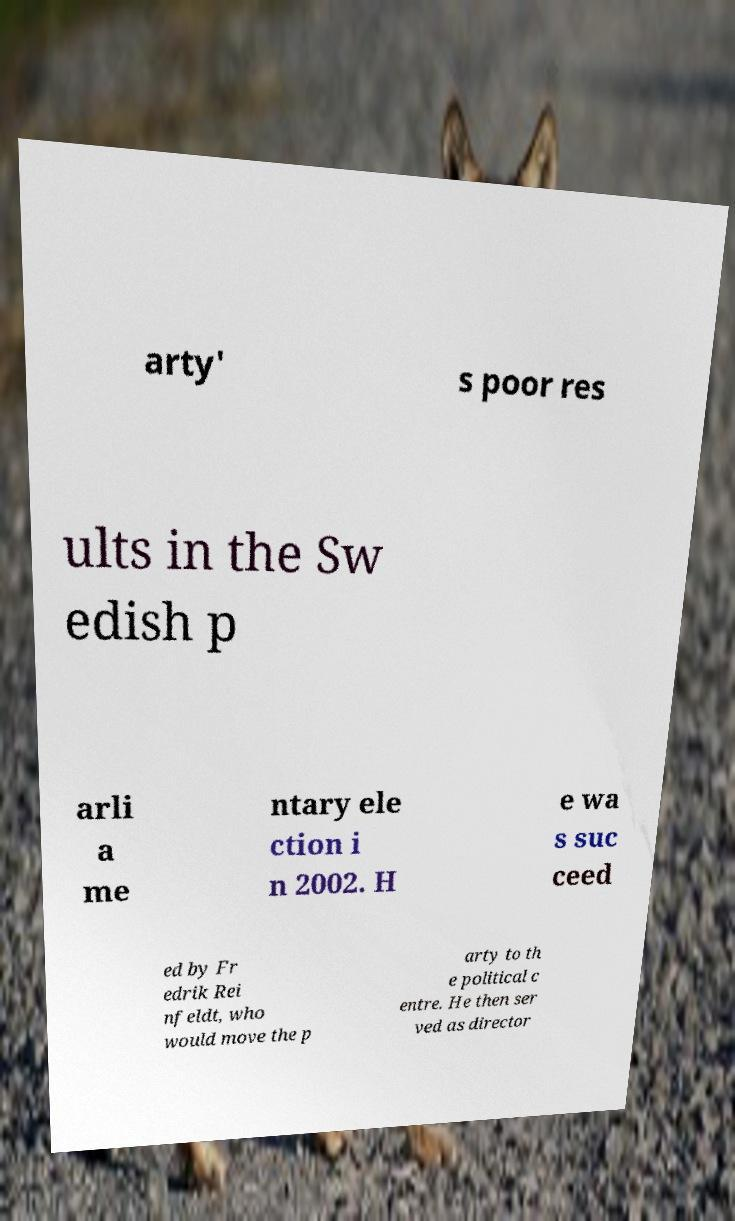I need the written content from this picture converted into text. Can you do that? arty' s poor res ults in the Sw edish p arli a me ntary ele ction i n 2002. H e wa s suc ceed ed by Fr edrik Rei nfeldt, who would move the p arty to th e political c entre. He then ser ved as director 